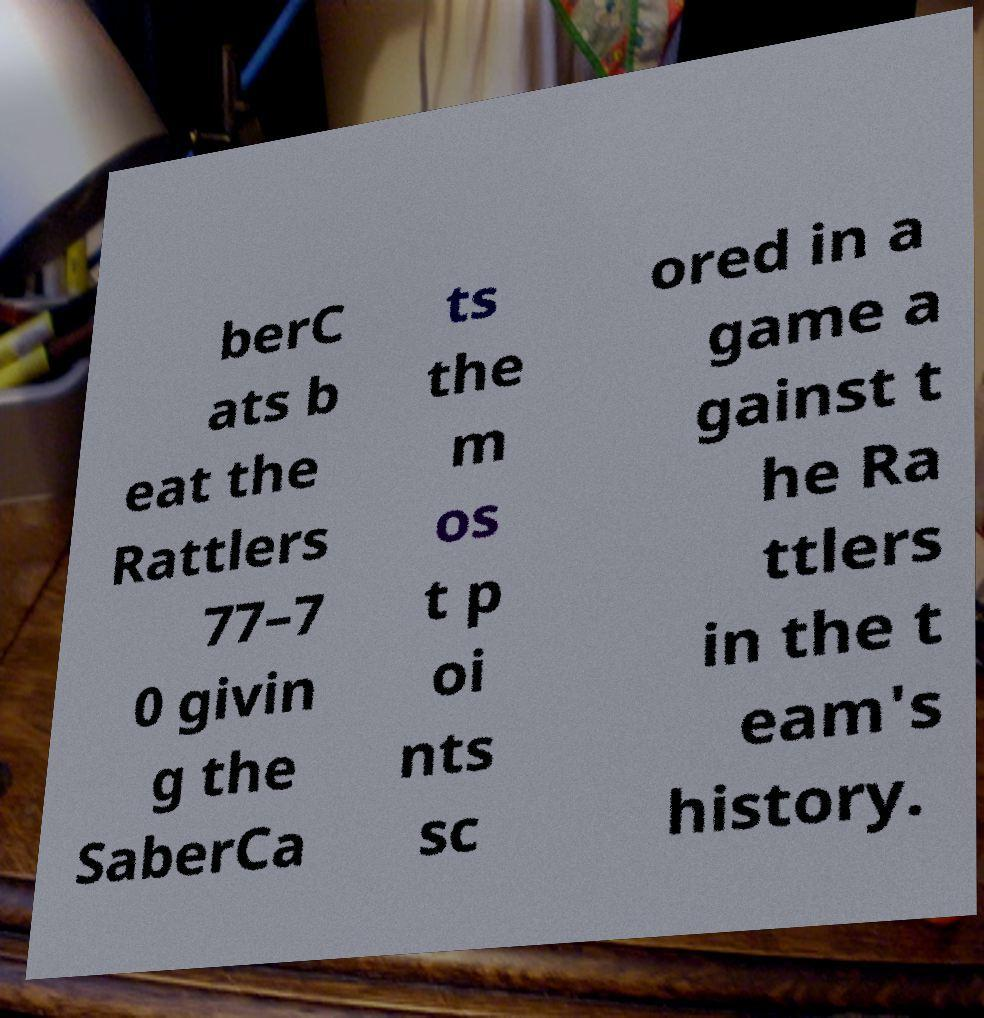Could you assist in decoding the text presented in this image and type it out clearly? berC ats b eat the Rattlers 77–7 0 givin g the SaberCa ts the m os t p oi nts sc ored in a game a gainst t he Ra ttlers in the t eam's history. 